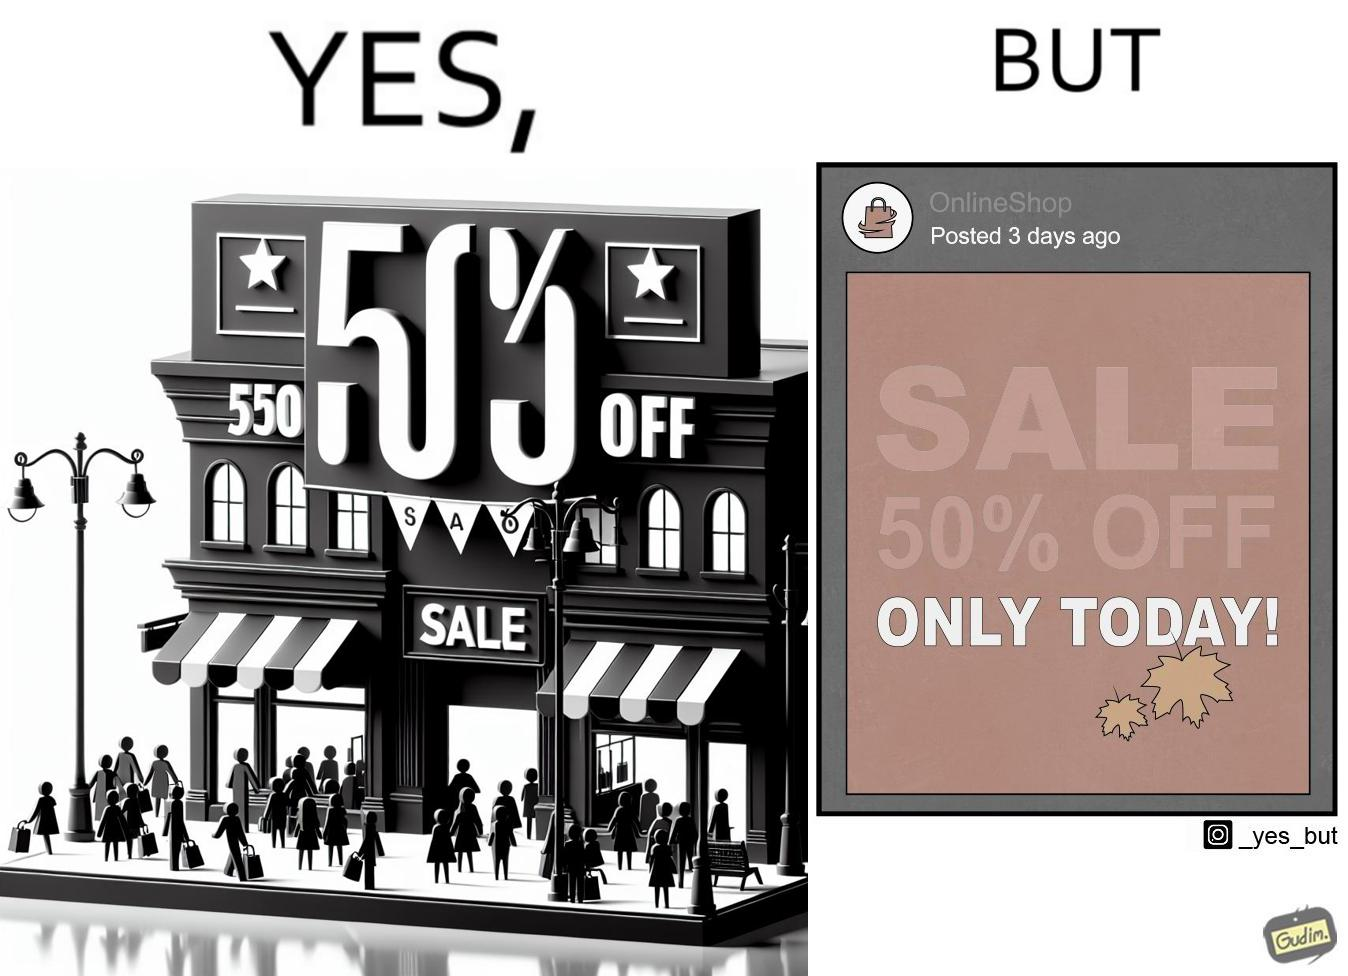Is there satirical content in this image? Yes, this image is satirical. 